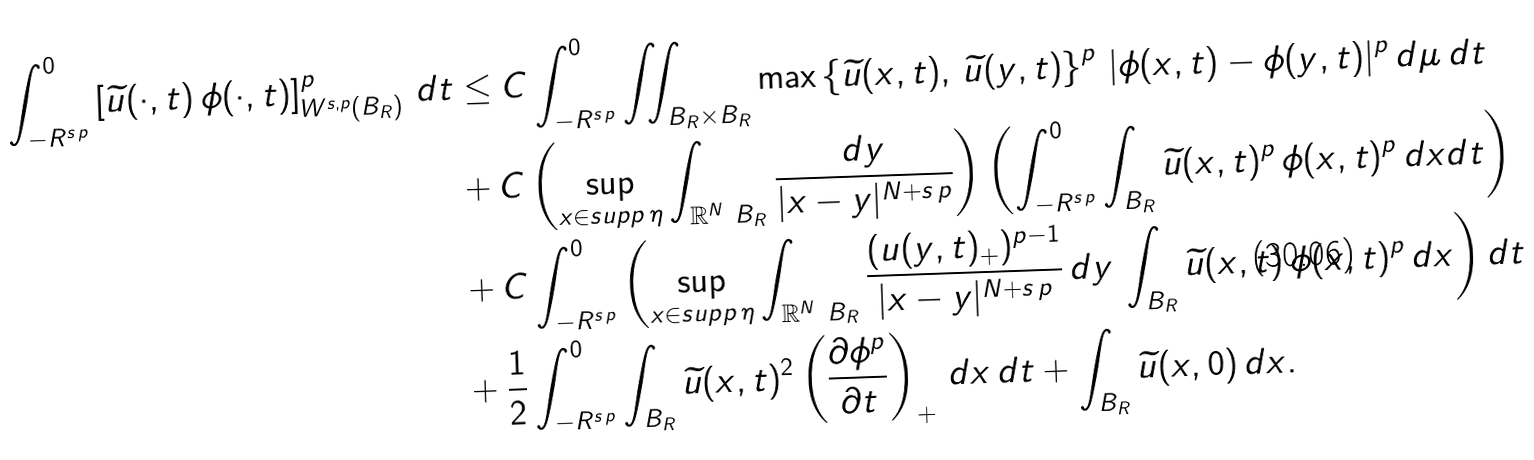<formula> <loc_0><loc_0><loc_500><loc_500>\int _ { - R ^ { s \, p } } ^ { 0 } \left [ \widetilde { u } ( \cdot , t ) \, \phi ( \cdot , t ) \right ] ^ { p } _ { W ^ { s , p } ( B _ { R } ) } \, d t & \leq C \int _ { - R ^ { s \, p } } ^ { 0 } \iint _ { B _ { R } \times B _ { R } } \max \left \{ \widetilde { u } ( x , t ) , \, \widetilde { u } ( y , t ) \right \} ^ { p } \, | \phi ( x , t ) - \phi ( y , t ) | ^ { p } \, d \mu \, d t \\ & + C \left ( \sup _ { x \in s u p p \, \eta } \int _ { \mathbb { R } ^ { N } \ B _ { R } } \frac { d y } { | x - y | ^ { N + s \, p } } \right ) \left ( \int _ { - R ^ { s \, p } } ^ { 0 } \int _ { B _ { R } } \widetilde { u } ( x , t ) ^ { p } \, \phi ( x , t ) ^ { p } \, d x d t \right ) \\ & + C \int _ { - R ^ { s \, p } } ^ { 0 } \left ( \sup _ { x \in s u p p \, \eta } \int _ { \mathbb { R } ^ { N } \ B _ { R } } \frac { ( u ( y , t ) _ { + } ) ^ { p - 1 } } { | x - y | ^ { N + s \, p } } \, d y \, \int _ { B _ { R } } \widetilde { u } ( x , t ) \, \phi ( x , t ) ^ { p } \, d x \right ) d t \\ & + \frac { 1 } { 2 } \int _ { - R ^ { s \, p } } ^ { 0 } \int _ { B _ { R } } \widetilde { u } ( x , t ) ^ { 2 } \left ( \frac { \partial \phi ^ { p } } { \partial t } \right ) _ { + } \, d x \, d t + \int _ { B _ { R } } \widetilde { u } ( x , 0 ) \, d x .</formula> 